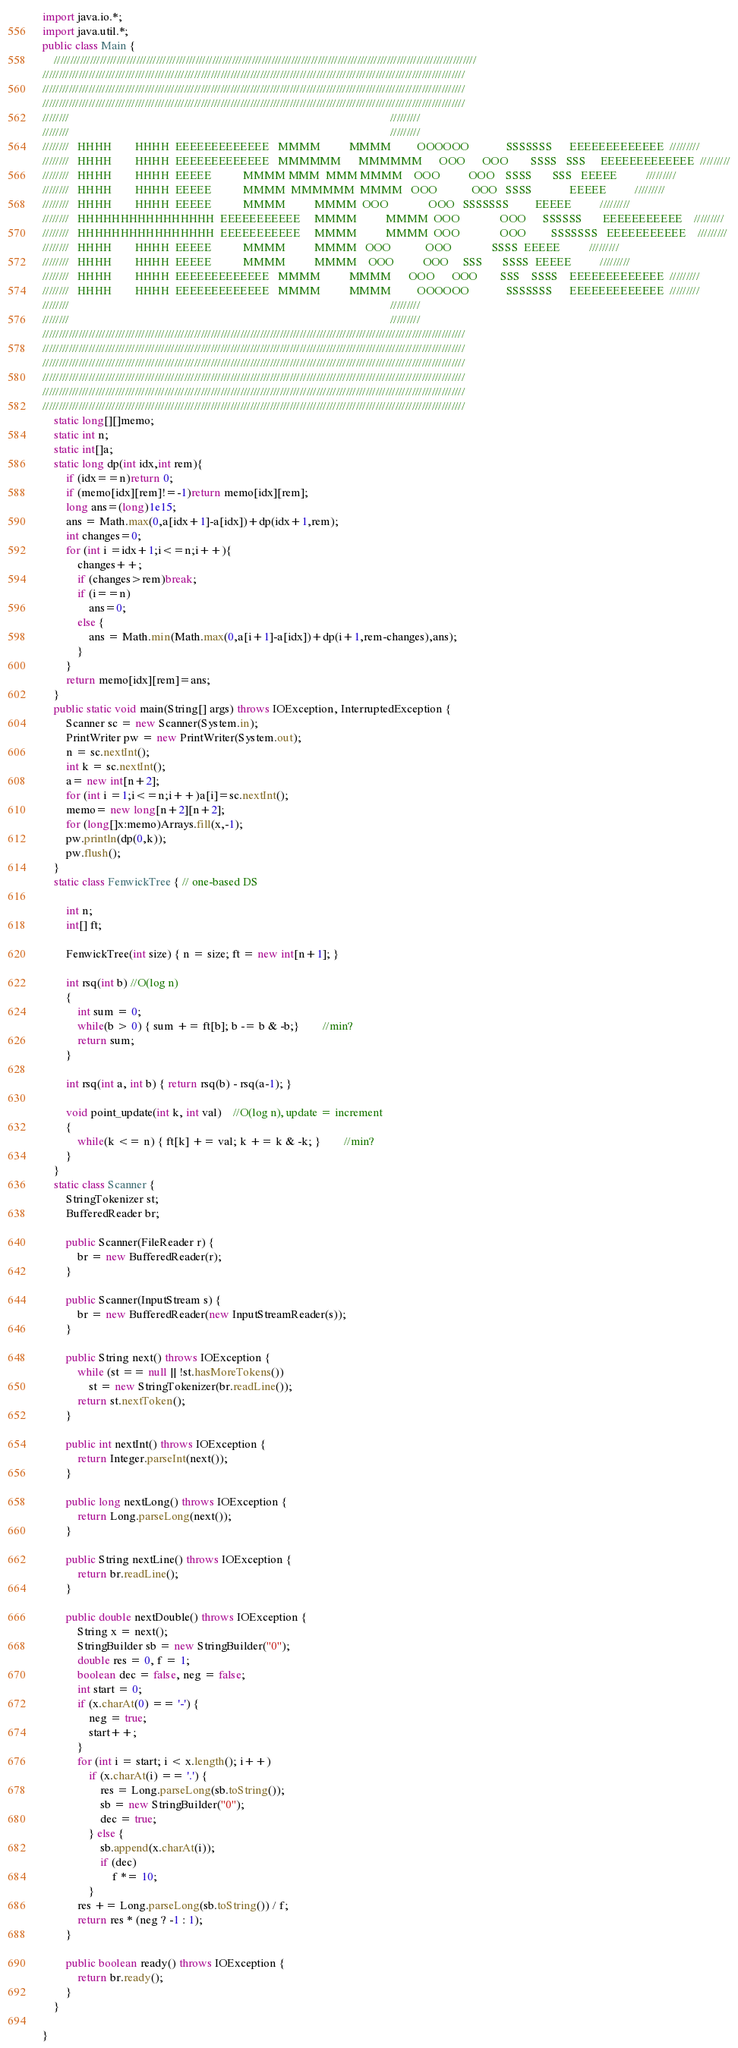<code> <loc_0><loc_0><loc_500><loc_500><_Java_>
import java.io.*;
import java.util.*;
public class Main {
    ////////////////////////////////////////////////////////////////////////////////////////////////////////////////////////////////
////////////////////////////////////////////////////////////////////////////////////////////////////////////////////////////////
////////////////////////////////////////////////////////////////////////////////////////////////////////////////////////////////
////////////////////////////////////////////////////////////////////////////////////////////////////////////////////////////////
////////                                                                                                               /////////
////////                                                                                                               /////////
////////   HHHH        HHHH  EEEEEEEEEEEEE   MMMM          MMMM         OOOOOO             SSSSSSS      EEEEEEEEEEEEE  /////////
////////   HHHH        HHHH  EEEEEEEEEEEEE   MMMMMM      MMMMMM      OOO      OOO        SSSS   SSS     EEEEEEEEEEEEE  /////////
////////   HHHH        HHHH  EEEEE           MMMM MMM  MMM MMMM    OOO          OOO    SSSS       SSS   EEEEE          /////////
////////   HHHH        HHHH  EEEEE           MMMM  MMMMMM  MMMM   OOO            OOO   SSSS             EEEEE          /////////
////////   HHHH        HHHH  EEEEE           MMMM          MMMM  OOO              OOO   SSSSSSS         EEEEE          /////////
////////   HHHHHHHHHHHHHHHH  EEEEEEEEEEE     MMMM          MMMM  OOO              OOO      SSSSSS       EEEEEEEEEEE    /////////
////////   HHHHHHHHHHHHHHHH  EEEEEEEEEEE     MMMM          MMMM  OOO              OOO         SSSSSSS   EEEEEEEEEEE    /////////
////////   HHHH        HHHH  EEEEE           MMMM          MMMM   OOO            OOO              SSSS  EEEEE          /////////
////////   HHHH        HHHH  EEEEE           MMMM          MMMM    OOO          OOO     SSS       SSSS  EEEEE          /////////
////////   HHHH        HHHH  EEEEEEEEEEEEE   MMMM          MMMM      OOO      OOO        SSS    SSSS    EEEEEEEEEEEEE  /////////
////////   HHHH        HHHH  EEEEEEEEEEEEE   MMMM          MMMM         OOOOOO             SSSSSSS      EEEEEEEEEEEEE  /////////
////////                                                                                                               /////////
////////                                                                                                               /////////
////////////////////////////////////////////////////////////////////////////////////////////////////////////////////////////////
////////////////////////////////////////////////////////////////////////////////////////////////////////////////////////////////
////////////////////////////////////////////////////////////////////////////////////////////////////////////////////////////////
////////////////////////////////////////////////////////////////////////////////////////////////////////////////////////////////
////////////////////////////////////////////////////////////////////////////////////////////////////////////////////////////////
////////////////////////////////////////////////////////////////////////////////////////////////////////////////////////////////
    static long[][]memo;
    static int n;
    static int[]a;
    static long dp(int idx,int rem){
        if (idx==n)return 0;
        if (memo[idx][rem]!=-1)return memo[idx][rem];
        long ans=(long)1e15;
        ans = Math.max(0,a[idx+1]-a[idx])+dp(idx+1,rem);
        int changes=0;
        for (int i =idx+1;i<=n;i++){
            changes++;
            if (changes>rem)break;
            if (i==n)
                ans=0;
            else {
                ans = Math.min(Math.max(0,a[i+1]-a[idx])+dp(i+1,rem-changes),ans);
            }
        }
        return memo[idx][rem]=ans;
    }
    public static void main(String[] args) throws IOException, InterruptedException {
        Scanner sc = new Scanner(System.in);
        PrintWriter pw = new PrintWriter(System.out);
        n = sc.nextInt();
        int k = sc.nextInt();
        a= new int[n+2];
        for (int i =1;i<=n;i++)a[i]=sc.nextInt();
        memo= new long[n+2][n+2];
        for (long[]x:memo)Arrays.fill(x,-1);
        pw.println(dp(0,k));
        pw.flush();
    }
    static class FenwickTree { // one-based DS

        int n;
        int[] ft;

        FenwickTree(int size) { n = size; ft = new int[n+1]; }

        int rsq(int b) //O(log n)
        {
            int sum = 0;
            while(b > 0) { sum += ft[b]; b -= b & -b;}		//min?
            return sum;
        }

        int rsq(int a, int b) { return rsq(b) - rsq(a-1); }

        void point_update(int k, int val)	//O(log n), update = increment
        {
            while(k <= n) { ft[k] += val; k += k & -k; }		//min?
        }
    }
    static class Scanner {
        StringTokenizer st;
        BufferedReader br;

        public Scanner(FileReader r) {
            br = new BufferedReader(r);
        }

        public Scanner(InputStream s) {
            br = new BufferedReader(new InputStreamReader(s));
        }

        public String next() throws IOException {
            while (st == null || !st.hasMoreTokens())
                st = new StringTokenizer(br.readLine());
            return st.nextToken();
        }

        public int nextInt() throws IOException {
            return Integer.parseInt(next());
        }

        public long nextLong() throws IOException {
            return Long.parseLong(next());
        }

        public String nextLine() throws IOException {
            return br.readLine();
        }

        public double nextDouble() throws IOException {
            String x = next();
            StringBuilder sb = new StringBuilder("0");
            double res = 0, f = 1;
            boolean dec = false, neg = false;
            int start = 0;
            if (x.charAt(0) == '-') {
                neg = true;
                start++;
            }
            for (int i = start; i < x.length(); i++)
                if (x.charAt(i) == '.') {
                    res = Long.parseLong(sb.toString());
                    sb = new StringBuilder("0");
                    dec = true;
                } else {
                    sb.append(x.charAt(i));
                    if (dec)
                        f *= 10;
                }
            res += Long.parseLong(sb.toString()) / f;
            return res * (neg ? -1 : 1);
        }

        public boolean ready() throws IOException {
            return br.ready();
        }
    }

}</code> 